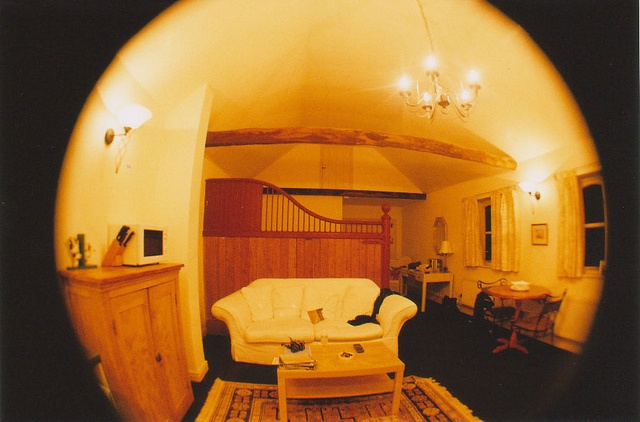Describe the objects in this image and their specific colors. I can see couch in black, orange, and red tones, microwave in black, orange, and maroon tones, chair in black, maroon, and brown tones, dining table in black, red, brown, and orange tones, and chair in black, maroon, brown, and orange tones in this image. 